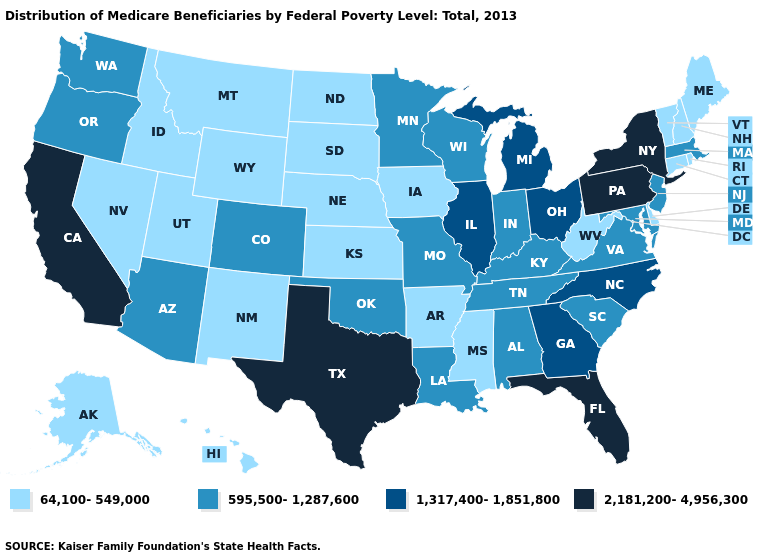What is the highest value in states that border Louisiana?
Give a very brief answer. 2,181,200-4,956,300. What is the lowest value in states that border Connecticut?
Be succinct. 64,100-549,000. Does Missouri have the same value as Kentucky?
Write a very short answer. Yes. What is the lowest value in the MidWest?
Concise answer only. 64,100-549,000. Does the first symbol in the legend represent the smallest category?
Concise answer only. Yes. What is the highest value in the USA?
Short answer required. 2,181,200-4,956,300. Among the states that border South Dakota , does Minnesota have the lowest value?
Answer briefly. No. Which states hav the highest value in the Northeast?
Keep it brief. New York, Pennsylvania. Does Alabama have a higher value than New Hampshire?
Keep it brief. Yes. Does Alabama have the same value as Rhode Island?
Concise answer only. No. Which states have the lowest value in the USA?
Concise answer only. Alaska, Arkansas, Connecticut, Delaware, Hawaii, Idaho, Iowa, Kansas, Maine, Mississippi, Montana, Nebraska, Nevada, New Hampshire, New Mexico, North Dakota, Rhode Island, South Dakota, Utah, Vermont, West Virginia, Wyoming. Does Arkansas have the lowest value in the South?
Quick response, please. Yes. Name the states that have a value in the range 2,181,200-4,956,300?
Write a very short answer. California, Florida, New York, Pennsylvania, Texas. Does West Virginia have a lower value than Utah?
Answer briefly. No. What is the highest value in the USA?
Write a very short answer. 2,181,200-4,956,300. 